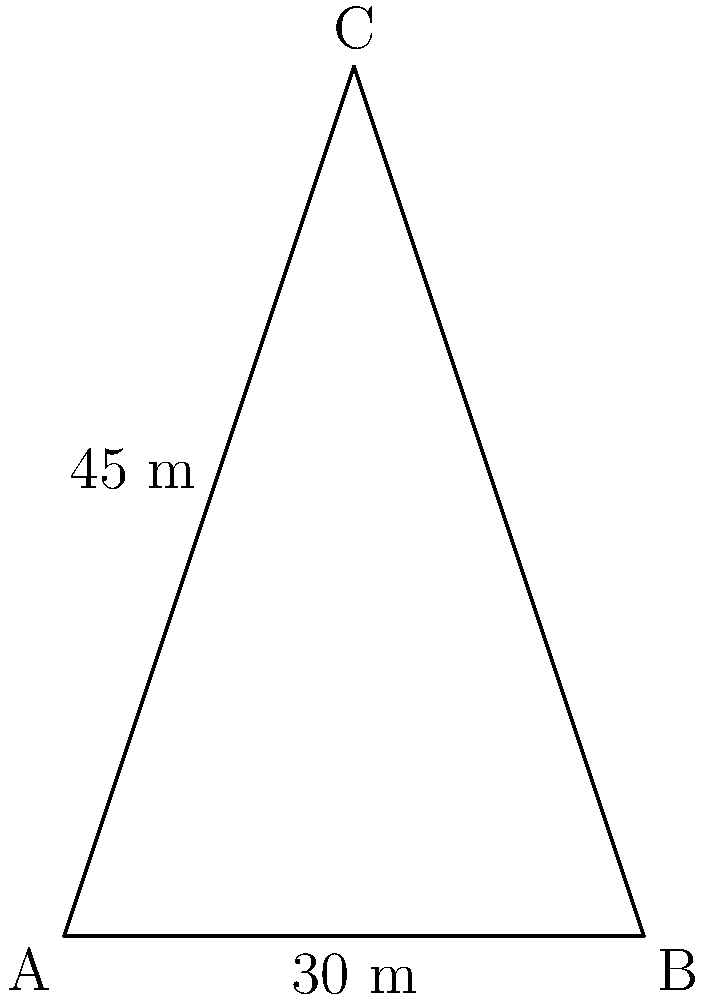In your study of Early Christian architecture, you encounter a church with a distinctive spire. The base width of the spire is 30 meters, and its height is 45 meters. What is the angle of inclination (in degrees) of the spire with respect to the ground? To find the angle of inclination, we can use trigonometry, specifically the tangent function. Let's approach this step-by-step:

1) In the right triangle formed by the spire and its base:
   - The adjacent side (half of the base width) is 15 meters (30/2)
   - The opposite side (height) is 45 meters

2) The tangent of the angle of inclination ($\theta$) is the ratio of the opposite side to the adjacent side:

   $$\tan(\theta) = \frac{\text{opposite}}{\text{adjacent}} = \frac{45}{15} = 3$$

3) To find the angle, we need to use the inverse tangent (arctangent) function:

   $$\theta = \arctan(3)$$

4) Using a calculator or mathematical tables:

   $$\theta \approx 71.57^\circ$$

5) Rounding to two decimal places:

   $$\theta \approx 71.57^\circ$$

This angle represents the inclination of the spire with respect to the ground.
Answer: $71.57^\circ$ 